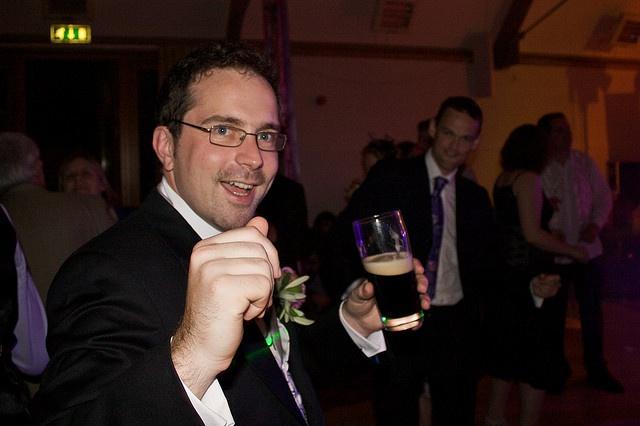Describe the objects in this image and their specific colors. I can see people in black, brown, tan, and lightgray tones, people in black, gray, maroon, and purple tones, people in black and maroon tones, people in black and purple tones, and people in black and purple tones in this image. 